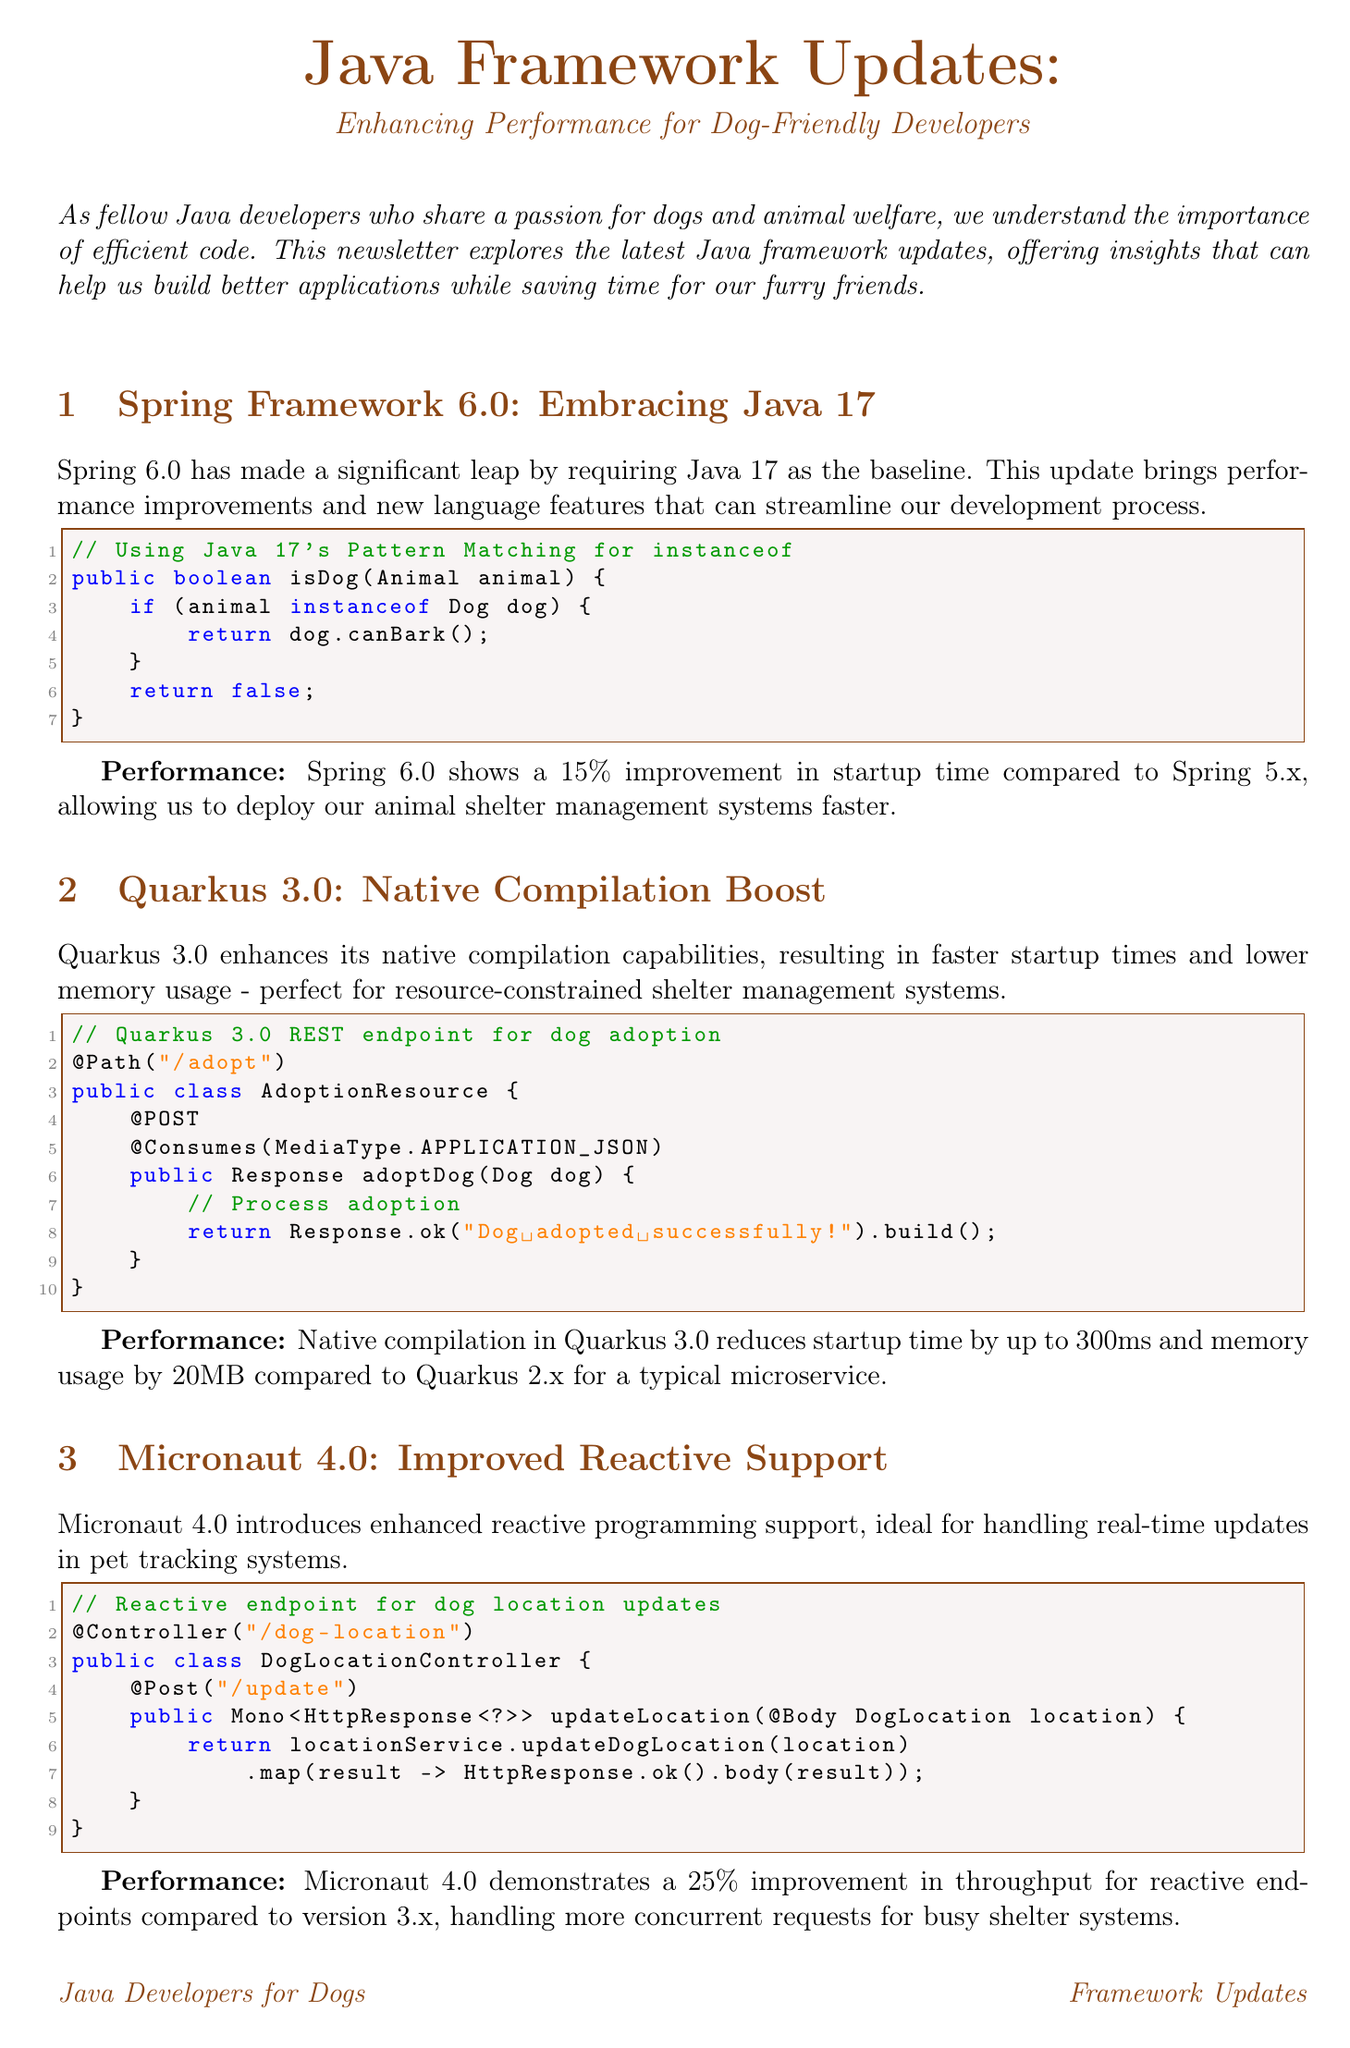What is the title of the newsletter? The title of the newsletter is stated at the beginning of the document.
Answer: Java Framework Updates: Enhancing Performance for Dog-Friendly Developers How much improvement in startup time does Spring 6.0 show? The specific improvement in startup time for Spring 6.0 is mentioned in the performance section.
Answer: 15% What version of Java is required by Spring Framework 6.0? The document specifically states the required Java version for Spring Framework 6.0.
Answer: Java 17 What is the native compilation startup time reduction for Quarkus 3.0? The startup time reduction for Quarkus 3.0 is detailed in its performance section.
Answer: 300ms What percentage improvement in throughput does Micronaut 4.0 demonstrate? The performance section for Micronaut 4.0 mentions the improvement percentage.
Answer: 25% What type of support does Micronaut 4.0 enhance? The document describes a specific programming approach that has been improved in Micronaut 4.0.
Answer: Reactive programming How is Jakarta EE 10 aimed at cloud-native development? The document outlines the overall focus and enhancement towards cloud-native applications.
Answer: Emphasizes cloud-native development What is the memory footprint reduction percentage for Jakarta EE 10 when deployed to the cloud? The performance impact of Jakarta EE 10 on memory footprint is mentioned in the document.
Answer: 10% What is the primary goal of the newsletter? The opening statement gives a concise overview of the newsletter's purpose and target audience.
Answer: Improve Java applications for animal shelters 